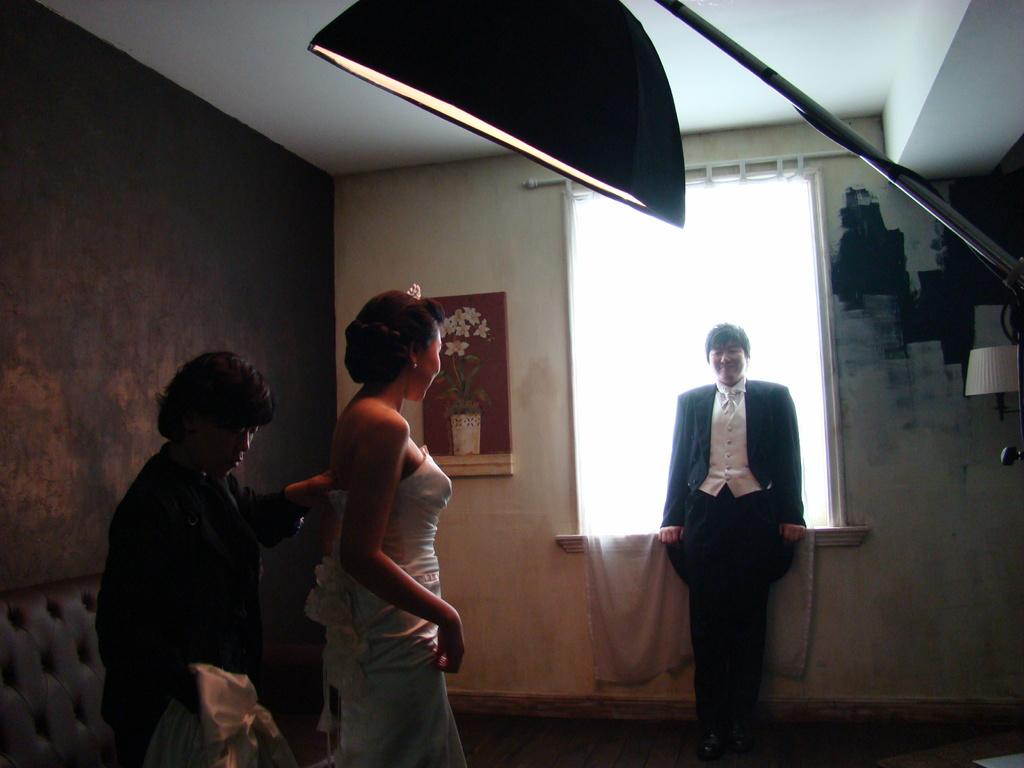How many women are in the image? There are two women standing in the left corner of the image. What can be seen in the image besides the women? There is a light stand in the image. Where is the other person located in the image? There is a person standing in the right corner of the image. What type of wool is the chicken wearing in the image? There is no chicken or wool present in the image. What holiday is being celebrated in the image? There is no indication of a holiday being celebrated in the image. 